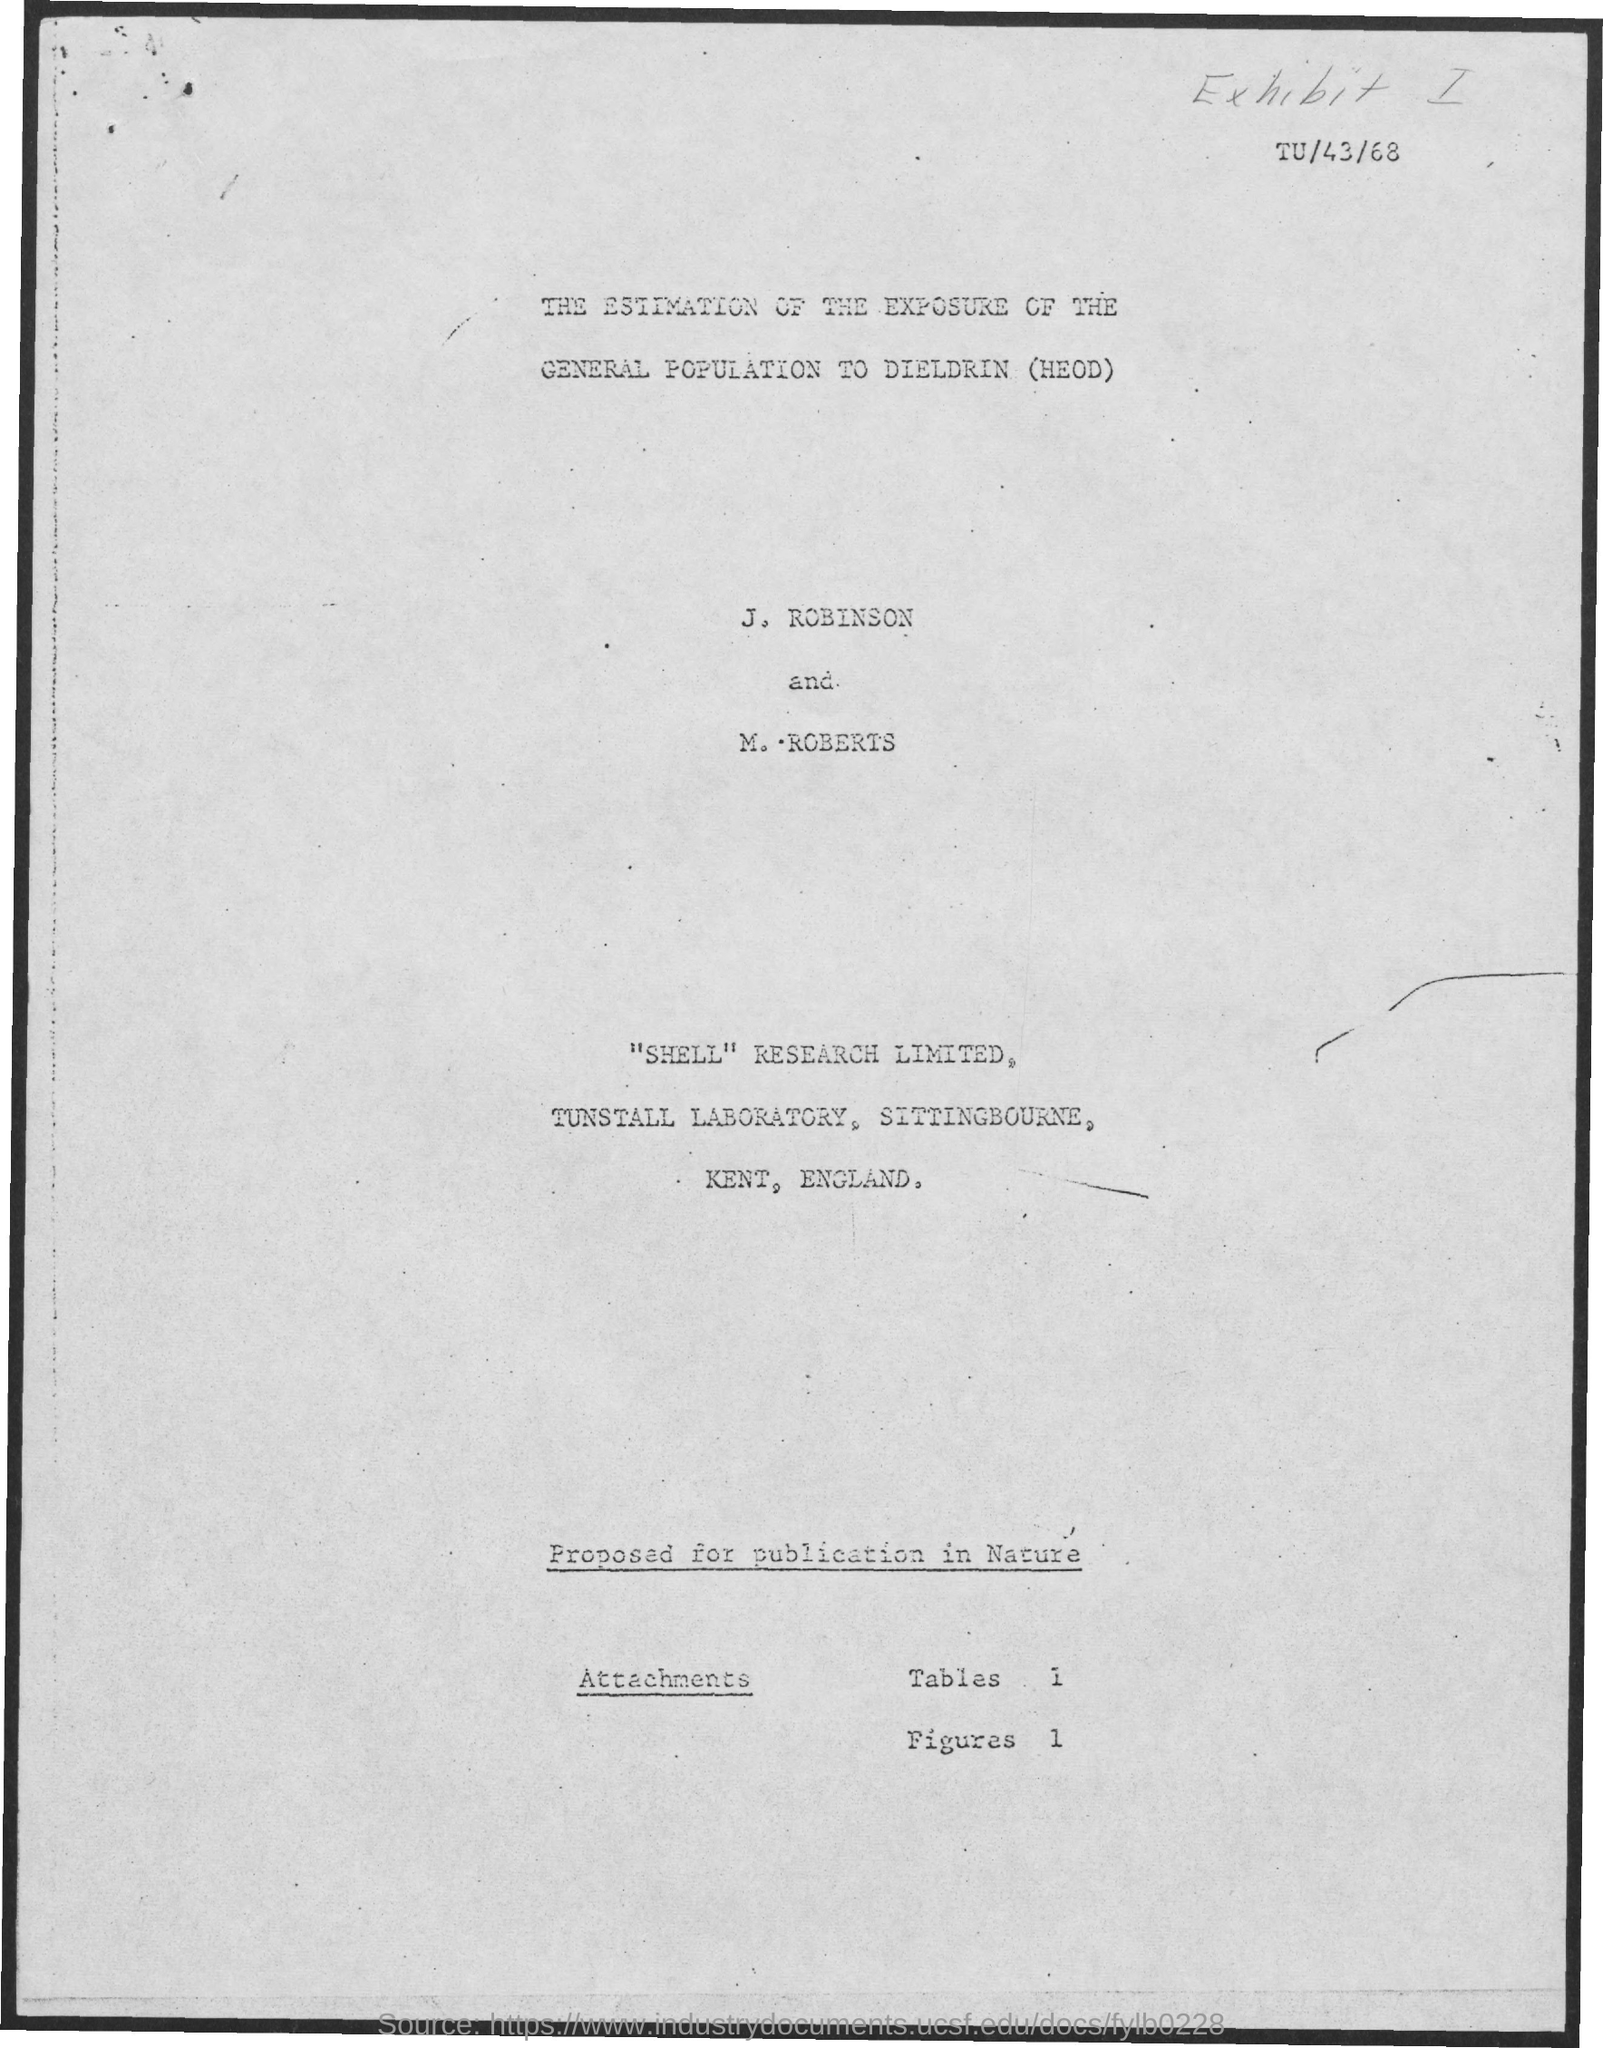Point out several critical features in this image. The names of the two individuals mentioned in the document are John Robinson and Mary Roberts. 